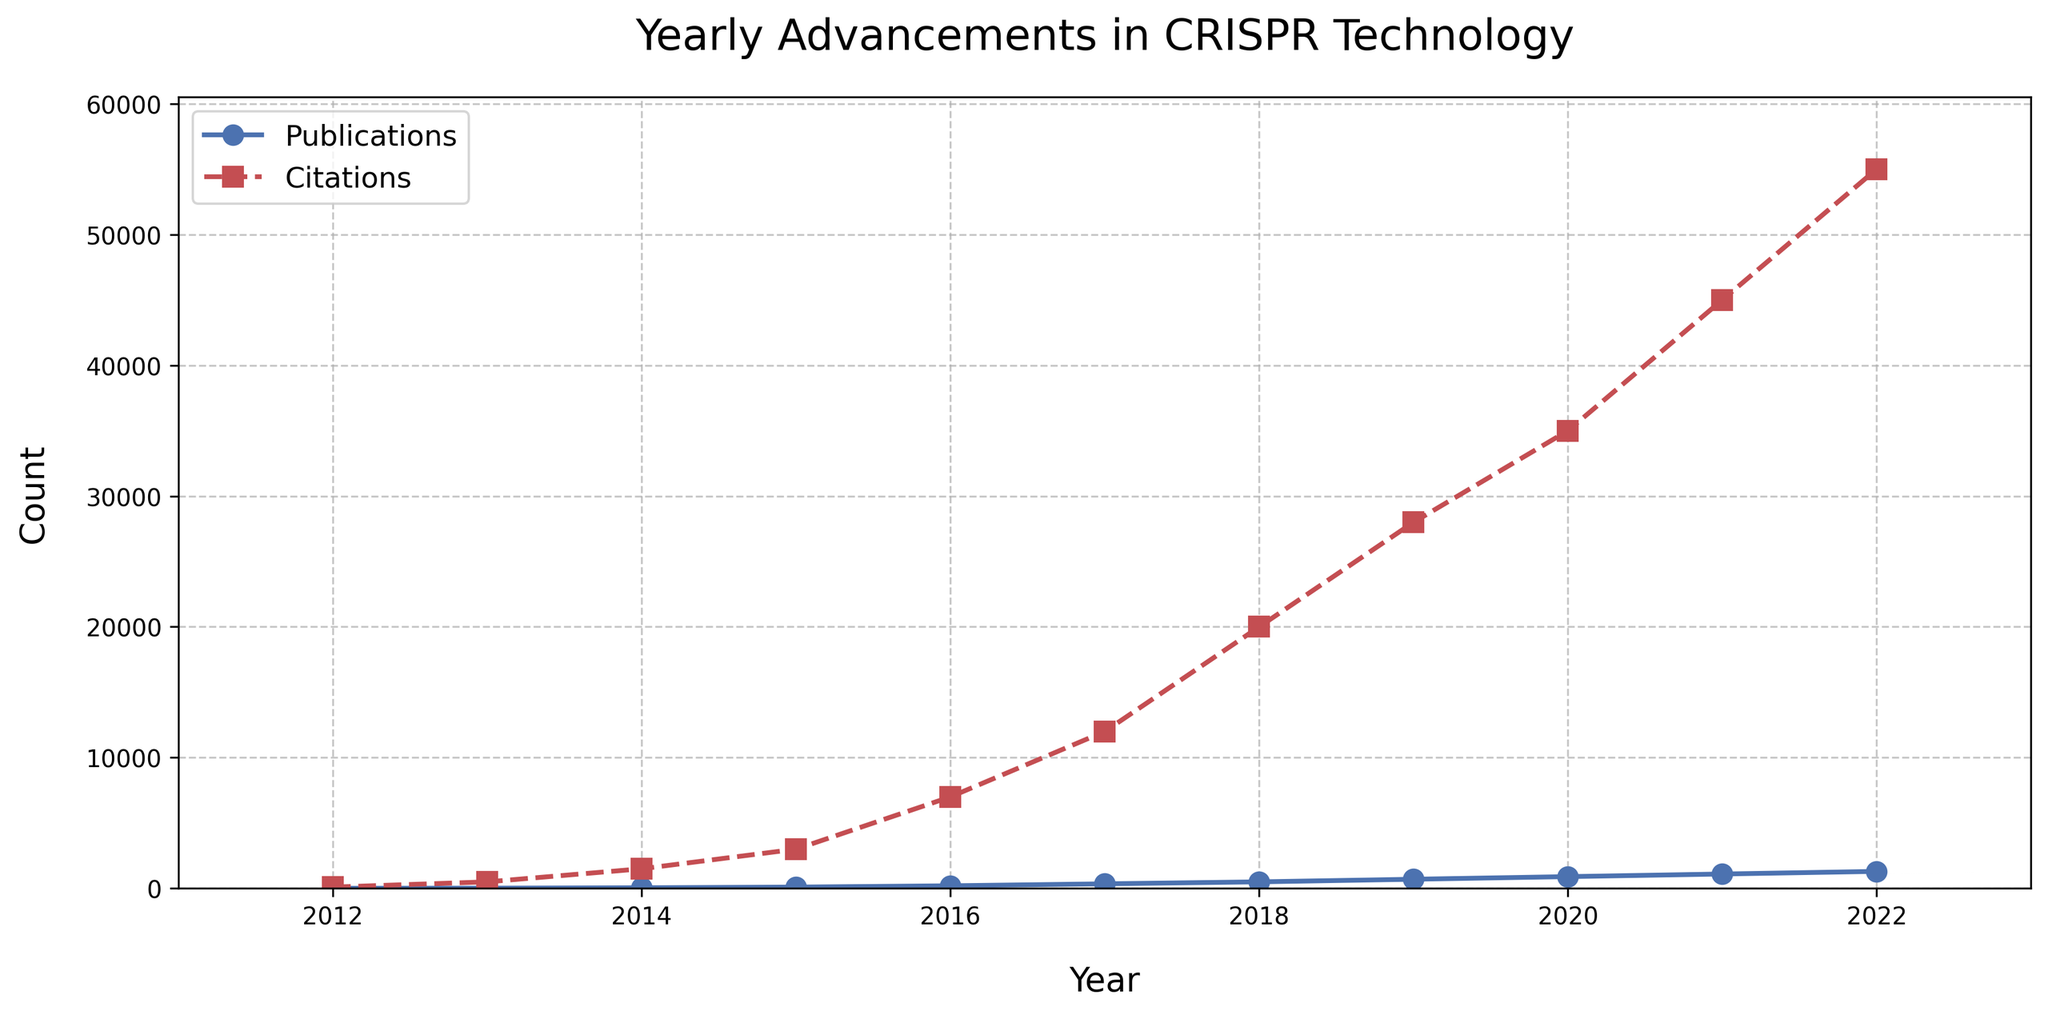What was the number of publications in 2015, and how does it compare to the number of publications in 2022? First, locate the data points of publications for the years 2015 and 2022 on the plot. The number of publications in 2015 is 100, and in 2022 it is 1300. Comparing these numbers: 1300 (2022) is greater than 100 (2015).
Answer: 1300 is greater than 100 What is the total count of citations from 2012 to 2014? Identify the citation counts for the years 2012 (100), 2013 (500), and 2014 (1500). Sum these values: 100 + 500 + 1500 = 2100.
Answer: 2100 In which year did the number of publications reach 200? Find the point where the 'Publications' curve first crosses the 200 mark on the y-axis. This occurs in the year 2016.
Answer: 2016 Did citations grow more rapidly between 2017-2018 or 2019-2020? Check the differences in citation counts: 2018 (20000) - 2017 (12000) = 8000, and 2020 (35000) - 2019 (28000) = 7000. The growth is 8000 (2017-2018) versus 7000 (2019-2020).
Answer: 2017-2018 What is the ratio of publications to citations in 2021? Identify the publication count (1100) and citation count (45000) for 2021. The ratio is calculated as 1100 / 45000 ≈ 0.024.
Answer: 0.024 Compare the increase in publications from 2018 to 2019 with the increase in citations during the same period. Publications increased from 500 (2018) to 700 (2019), an increase of 200. Citations increased from 20000 (2018) to 28000 (2019), an increase of 8000.
Answer: Publications: 200, Citations: 8000 Which year had the maximum number of citations and what was the count? Identify the peak value on the 'Citations' curve. The maximum citations are in 2022 with a count of 55000.
Answer: 2022, 55000 What are the color markers used for the line charts of publications and citations? Visually check the line colors: Publications are blue with 'o' markers, and Citations are red with 's' markers.
Answer: blue and red From 2015 to 2016, how much did the number of citations increase? Identify the citation counts for 2015 (3000) and 2016 (7000). The increase is 7000 - 3000 = 4000.
Answer: 4000 